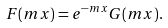Convert formula to latex. <formula><loc_0><loc_0><loc_500><loc_500>F ( m x ) = e ^ { - m x } G ( m x ) .</formula> 